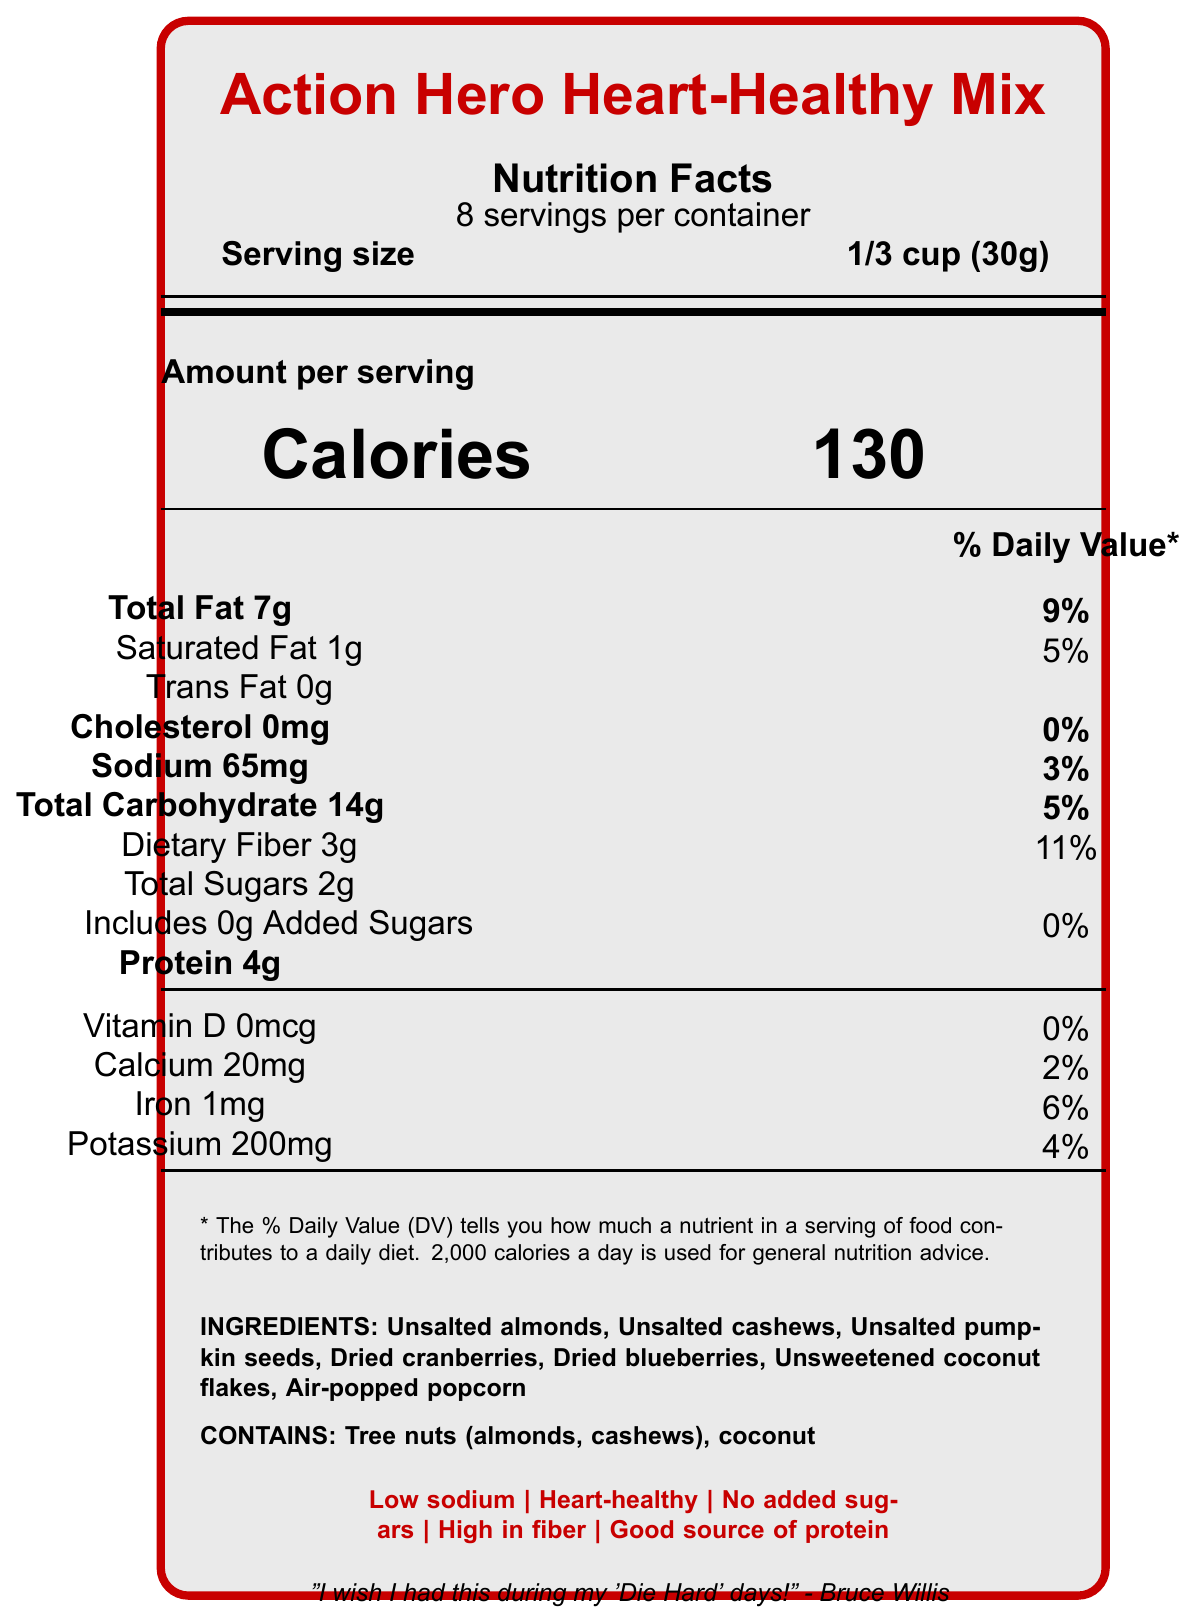what is the serving size? The nutrition label clearly specifies that the serving size is 1/3 cup (30g).
Answer: 1/3 cup (30g) how many calories are there per serving? The document states that there are 130 calories per serving.
Answer: 130 what is the total fat content per serving? The total fat content per serving is listed as 7g in the label.
Answer: 7g how much sodium does one serving contain? The label shows that each serving contains 65mg of sodium.
Answer: 65mg how much protein does one serving provide? Each serving provides 4g of protein according to the nutrition facts.
Answer: 4g which tree nuts are included in the ingredients? A. Almonds and peanuts B. Cashews and pistachios C. Almonds and cashews D. Peanuts and walnuts The ingredients list shows that unsalted almonds and unsalted cashews are included.
Answer: C what percentage of the daily value of dietary fiber does one serving provide? The label mentions that one serving provides 11% of the daily value for dietary fiber.
Answer: 11% which nutrients have a daily value of 0% per serving? A. Cholesterol and Vitamin D B. Total Fat and Iron C. Calcium and Potassium D. Protein and Sodium According to the label, the daily value for both cholesterol and Vitamin D per serving is 0%.
Answer: A does the snack mix contain any added sugars? The document states that the snack mix includes 0g of added sugars (0% daily value).
Answer: No is the snack mix endorsed by any action stars? The label includes an endorsement from Chuck Norris and a quote from Bruce Willis.
Answer: Yes summarize the main idea of the document The document provides comprehensive nutritional details about a heart-healthy snack mix, emphasizing its low sodium, no added sugars, and high-fiber benefits. It highlights endorsements from action stars to appeal to the target market of retired action professionals.
Answer: The document is a nutrition facts label for "Action Hero Heart-Healthy Mix," a low-sodium, heart-healthy snack mix endorsed by action movie stars and marketed towards retired action professionals. It includes detailed nutritional information, ingredients, allergen info, and marketing claims. what is the daily value percentage for potassium per serving? The document lists that the potassium content per serving is 200mg, which equates to 4% of the daily value.
Answer: 4% does the product contain any dairy ingredients? The document provides an ingredient list but does not specify whether any dairy ingredients are included or excluded.
Answer: Cannot be determined 